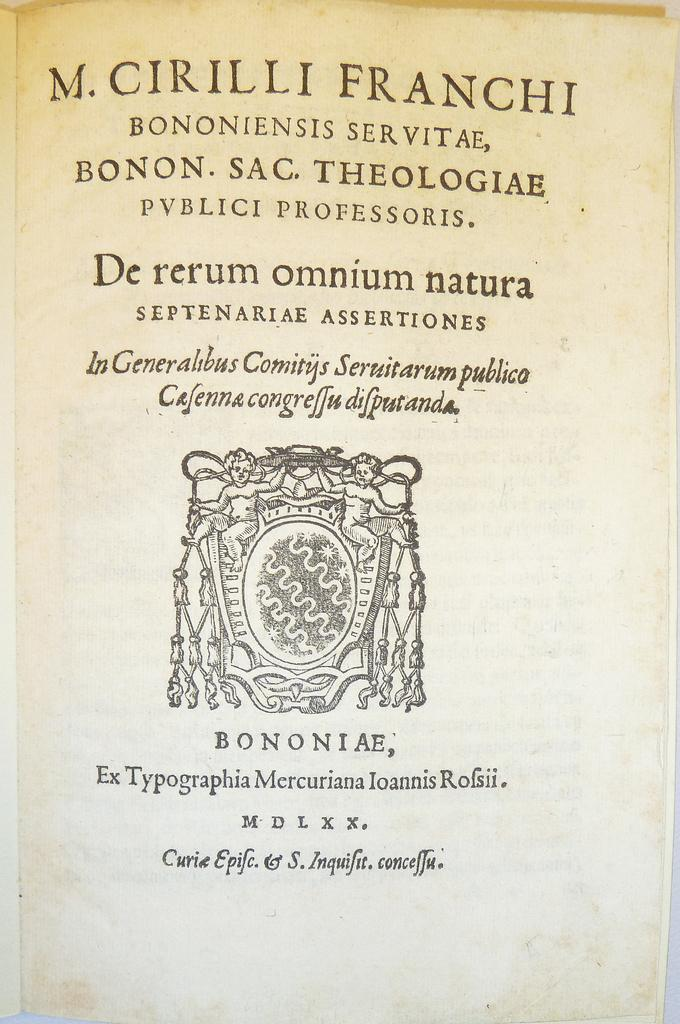What is present in the image that has text and a picture on it? There is a paper in the image that has text and a picture printed on it. Can you describe the content of the paper? The paper has text printed on it, as well as a picture. How many crows are sitting on the snakes in the image? There are no crows or snakes present in the image; it only features a paper with text and a picture on it. 